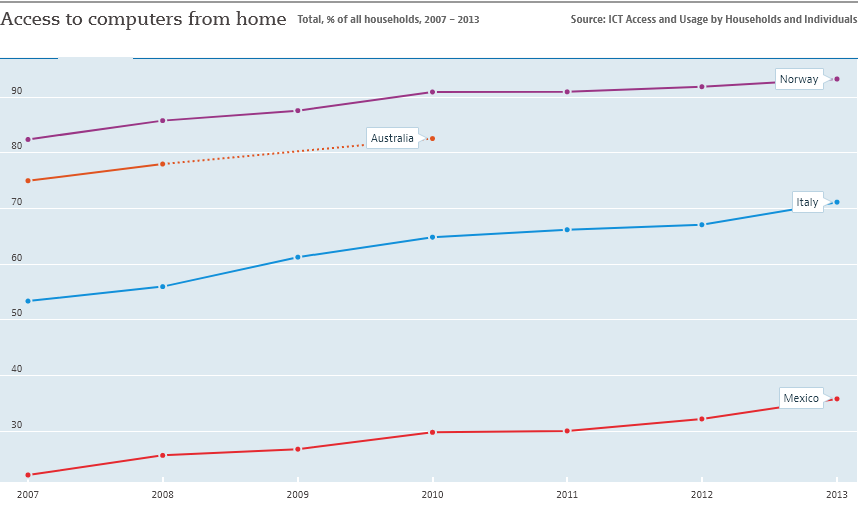Draw attention to some important aspects in this diagram. Mexico has the least access to computers from home among all countries. The graph displays data from 4 countries. 